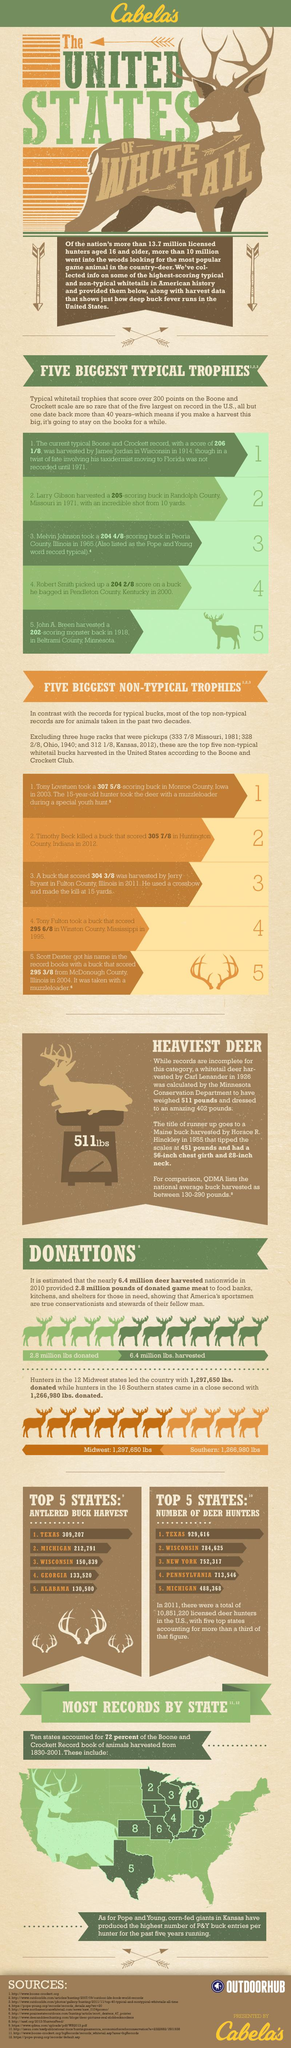Identify some key points in this picture. Michigan has the second highest number of antlered buck harvests among the states in the United States. According to recent data, there are approximately 929,616 deer hunters currently residing in the state of Texas. There are 488,368 deer hunters currently present in the state of Michigan. In Wisconsin, the number of Antlered Buck harvested in the year 2021 was 150,839. Pennsylvania has the second lowest number of deer hunters among all states. 